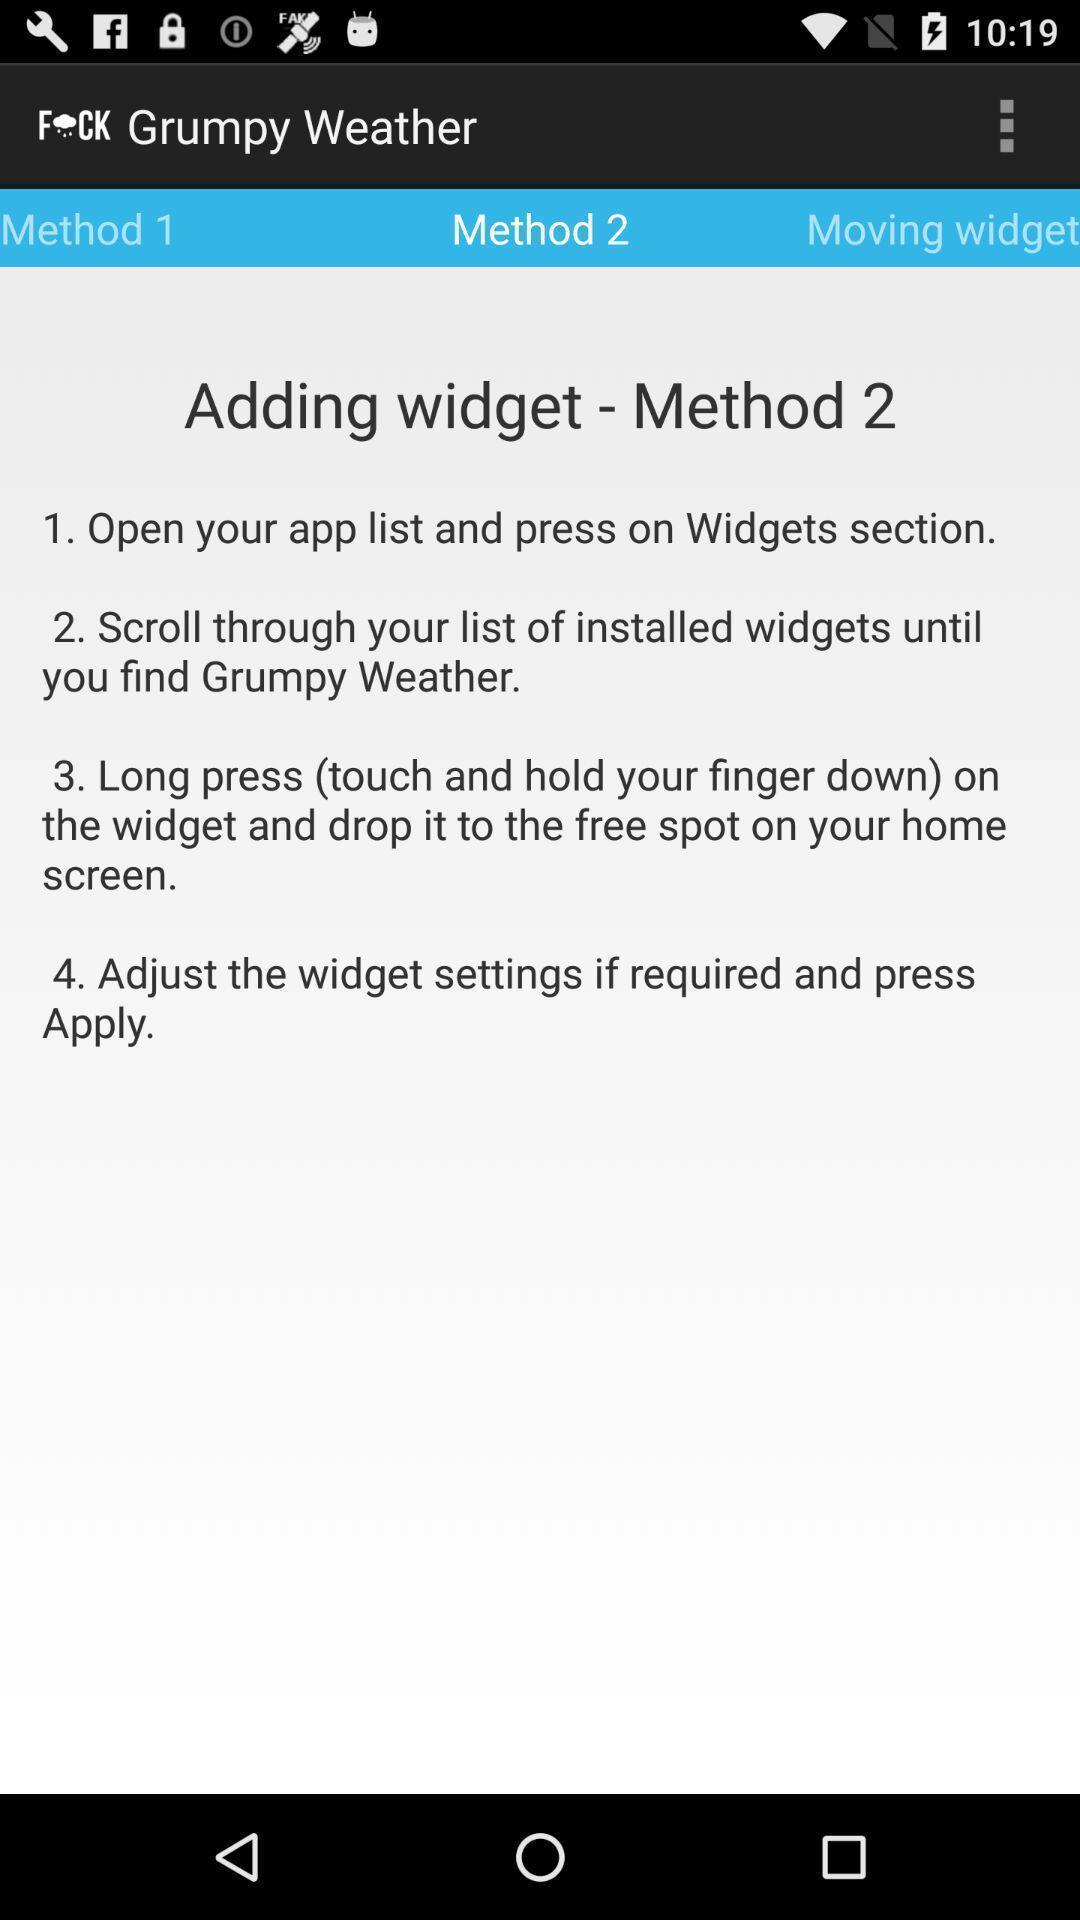Give me a narrative description of this picture. Screen shows number of methods in a weather app. 